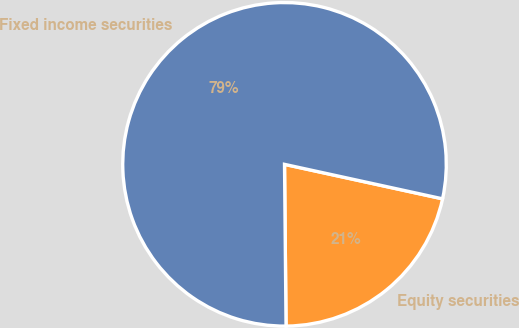Convert chart. <chart><loc_0><loc_0><loc_500><loc_500><pie_chart><fcel>Equity securities<fcel>Fixed income securities<nl><fcel>21.43%<fcel>78.57%<nl></chart> 